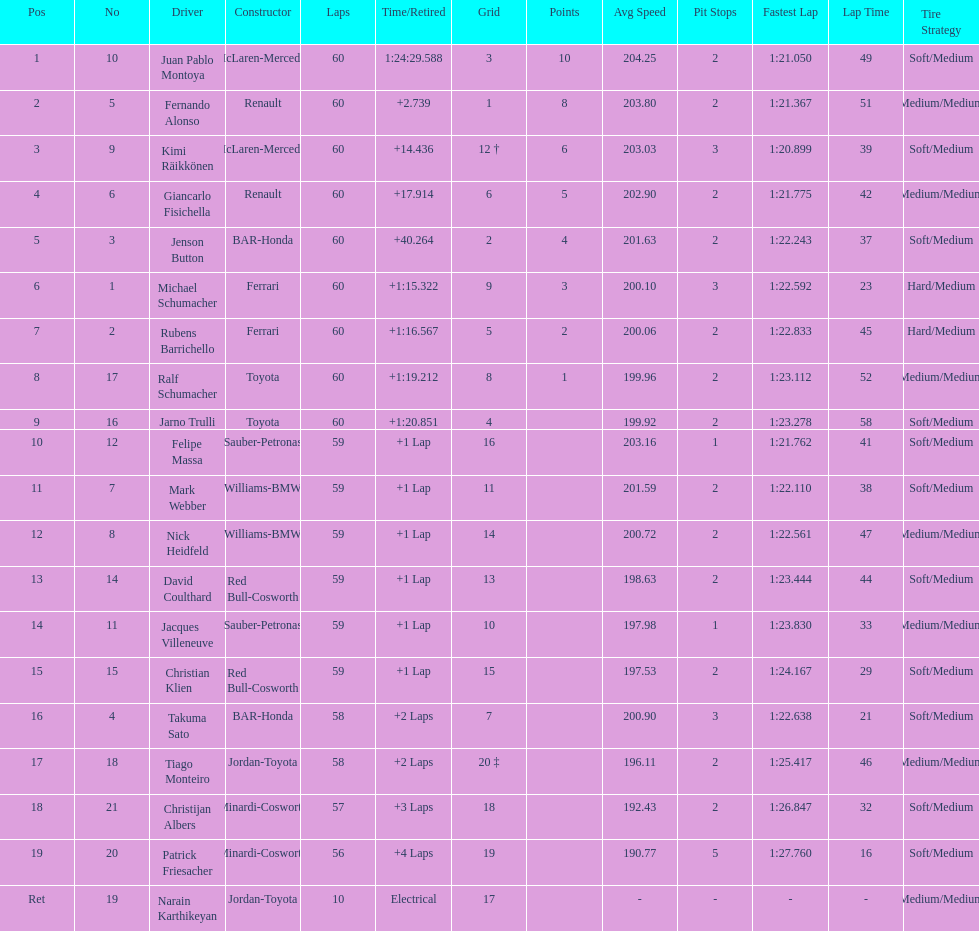Is there a points difference between the 9th position and 19th position on the list? No. 